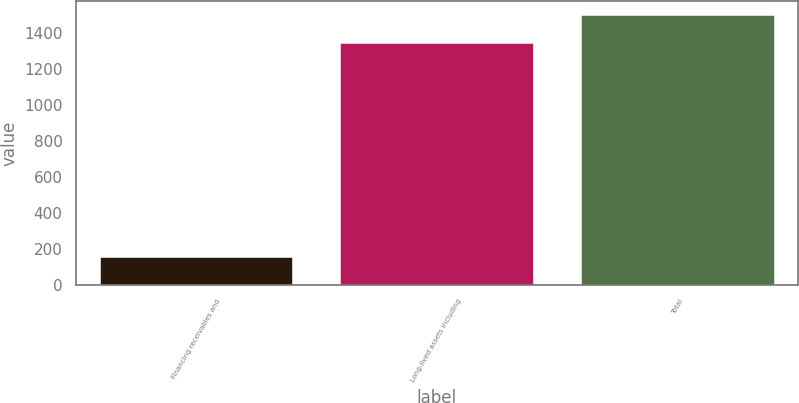Convert chart. <chart><loc_0><loc_0><loc_500><loc_500><bar_chart><fcel>Financing receivables and<fcel>Long-lived assets including<fcel>Total<nl><fcel>158<fcel>1343<fcel>1501<nl></chart> 